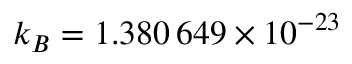<formula> <loc_0><loc_0><loc_500><loc_500>k _ { B } = 1 . 3 8 0 \, 6 4 9 \times 1 0 ^ { - 2 3 }</formula> 